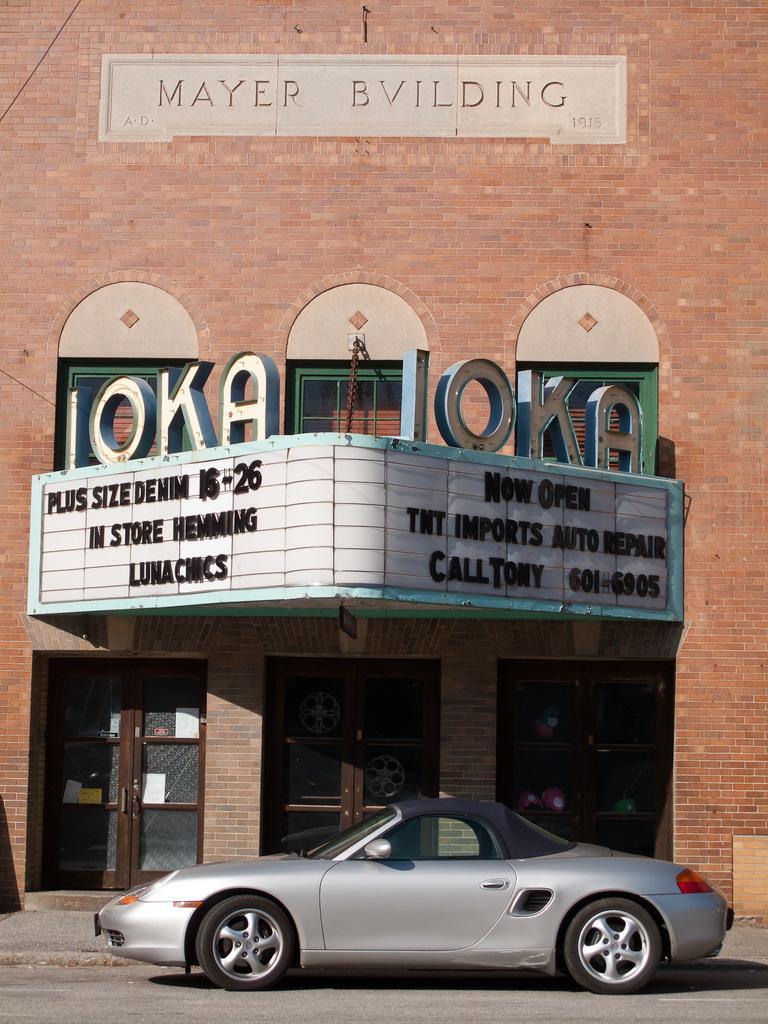Could you give a brief overview of what you see in this image? In this image I can see a road in the front and on it I can see a silver colour car. In the background I can see a building, few doors, few boards and on it I can see something is written. On the left side of the image I can see few white colour boards on the doors and on the top left corner of the image, I can see a wire like thing. 